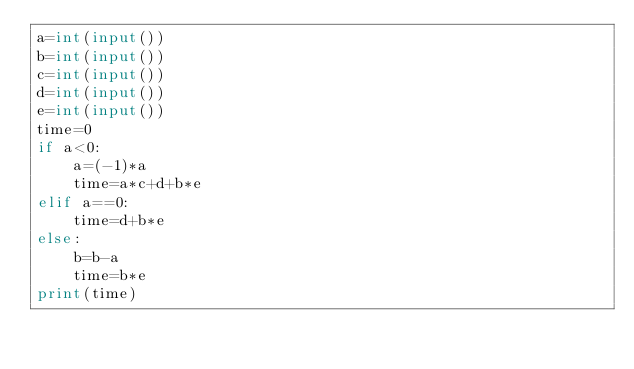<code> <loc_0><loc_0><loc_500><loc_500><_Python_>a=int(input())
b=int(input())
c=int(input())
d=int(input())
e=int(input())
time=0
if a<0:
    a=(-1)*a
    time=a*c+d+b*e
elif a==0:
    time=d+b*e
else:
    b=b-a
    time=b*e
print(time)

</code> 